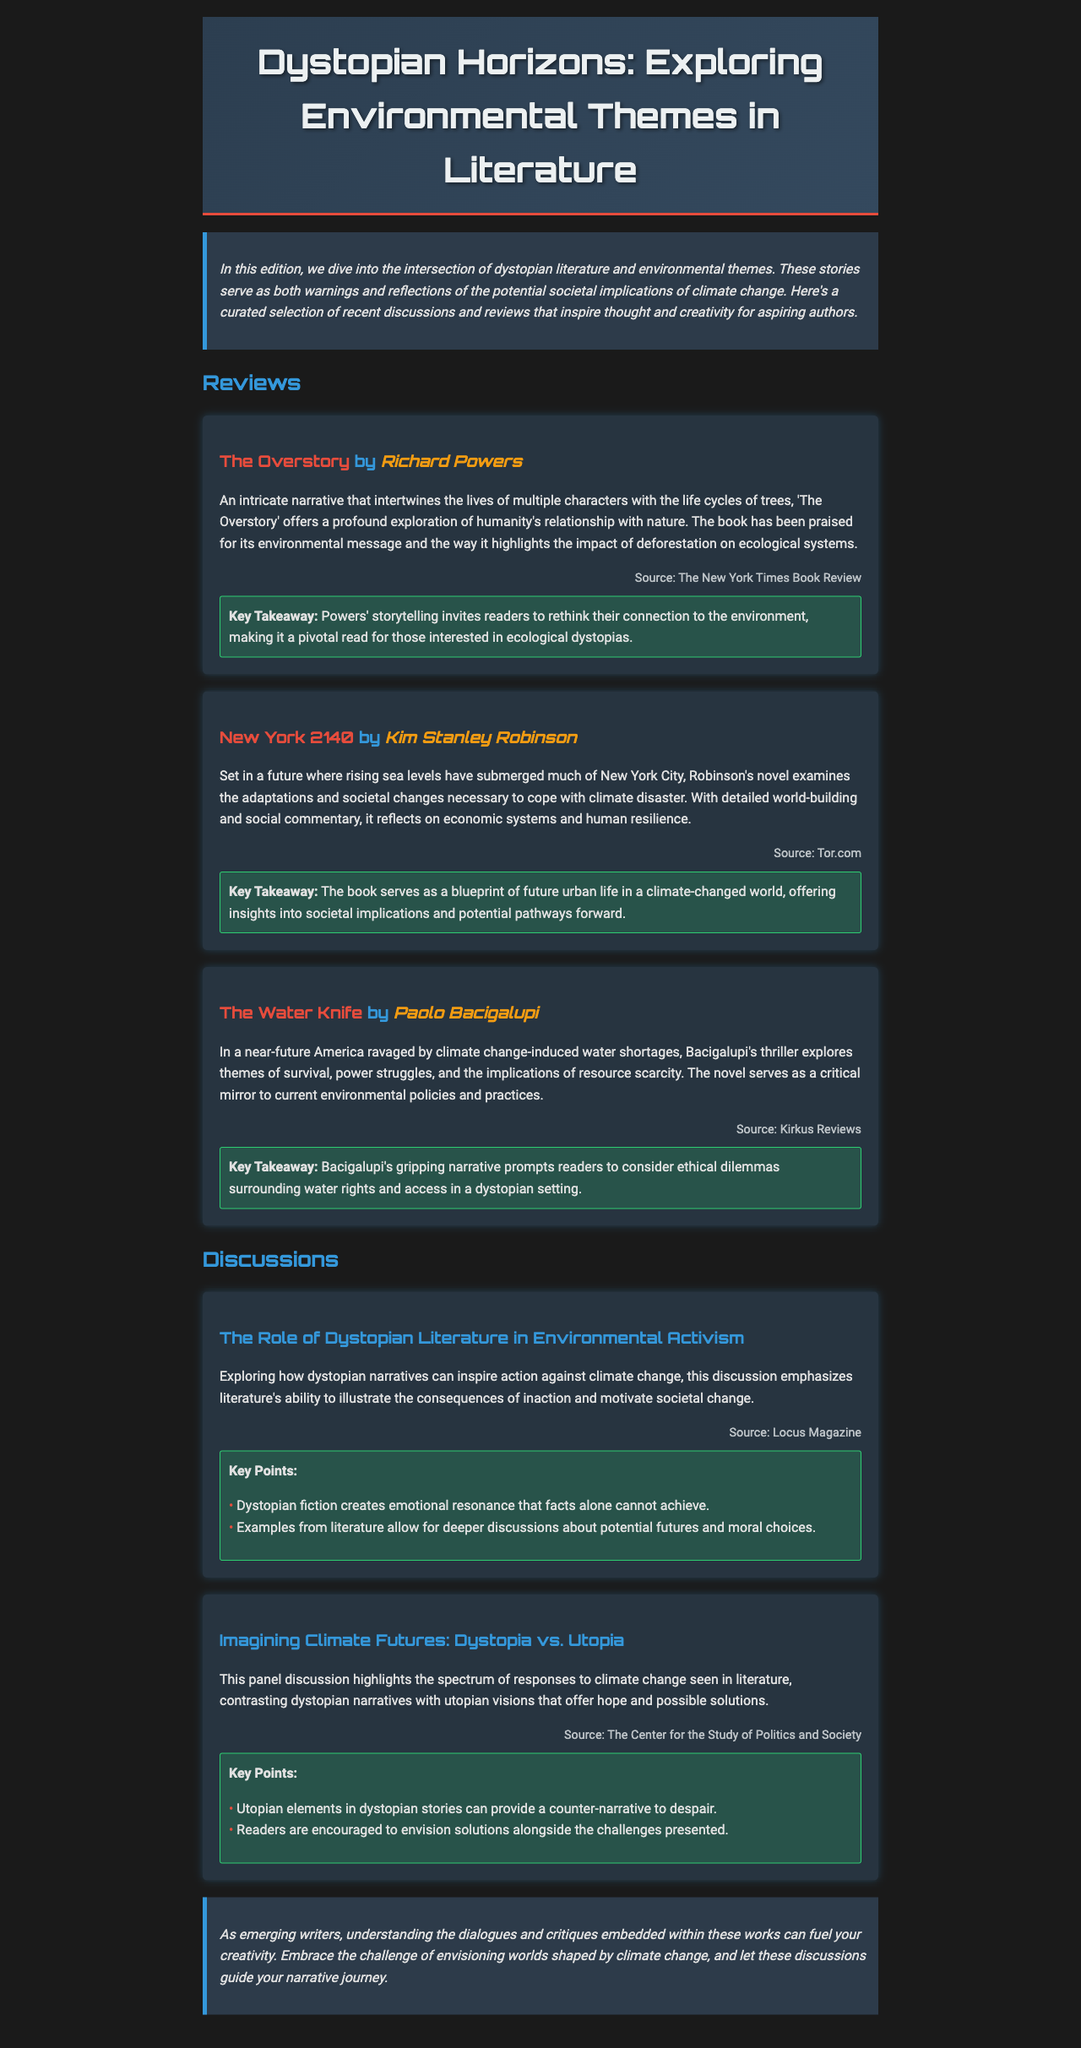what is the title of the newsletter? The title is prominently displayed at the top of the document.
Answer: Dystopian Horizons: Exploring Environmental Themes in Literature who is the author of "The Overstory"? The author of the book is mentioned directly with the title in the review section.
Answer: Richard Powers what is a key takeaway from "New York 2140"? Key takeaways are included in bold text under each review, summarizing the insights from the books.
Answer: The book serves as a blueprint of future urban life in a climate-changed world which magazine discussed the role of dystopian literature in environmental activism? The source of this discussion is cited under the corresponding section.
Answer: Locus Magazine what is a key point of the panel discussion comparing dystopia and utopia? Key points are summarized in bold text and list form in the discussion sections.
Answer: Utopian elements in dystopian stories can provide a counter-narrative to despair how many reviews are included in the document? The number of reviews can be counted under the reviews section.
Answer: Three what year is "New York 2140" set in? The setting of the book is specified in the review, indicating a future year.
Answer: 2140 what theme do "The Water Knife" and "The Overstory" share? The reviews highlight the central themes of each book, both relating to environmental issues.
Answer: Environmental themes 